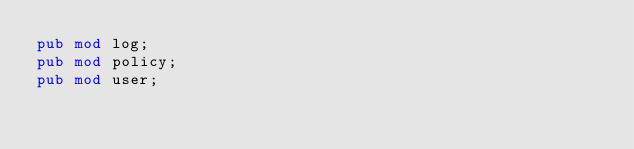Convert code to text. <code><loc_0><loc_0><loc_500><loc_500><_Rust_>pub mod log;
pub mod policy;
pub mod user;
</code> 